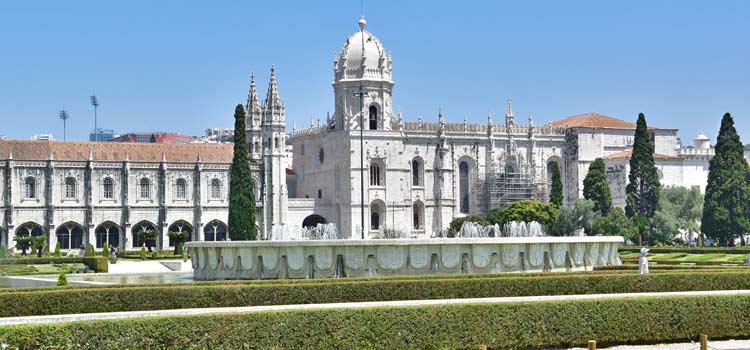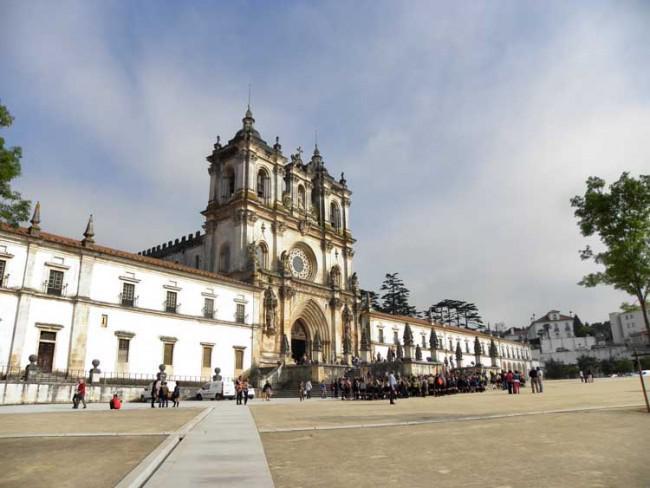The first image is the image on the left, the second image is the image on the right. Evaluate the accuracy of this statement regarding the images: "In one of the photos, there is at least one tree pictured in front of the buildings.". Is it true? Answer yes or no. Yes. The first image is the image on the left, the second image is the image on the right. Analyze the images presented: Is the assertion "A notched wall is behind an ornate facade with a circle above an arch, in one image." valid? Answer yes or no. Yes. 